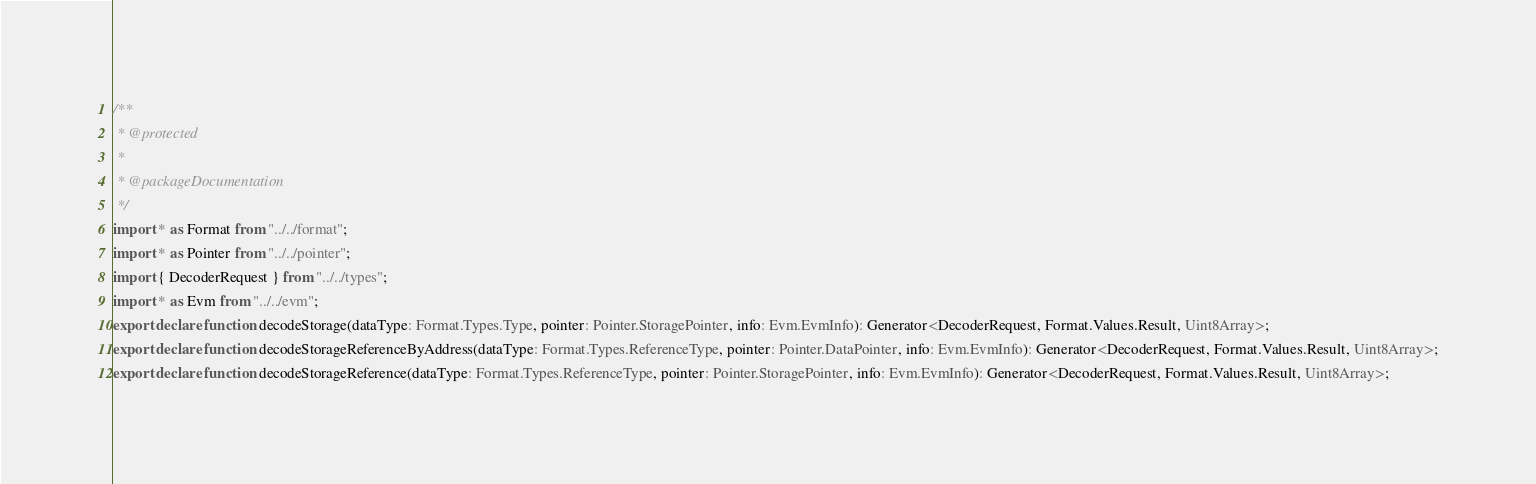Convert code to text. <code><loc_0><loc_0><loc_500><loc_500><_TypeScript_>/**
 * @protected
 *
 * @packageDocumentation
 */
import * as Format from "../../format";
import * as Pointer from "../../pointer";
import { DecoderRequest } from "../../types";
import * as Evm from "../../evm";
export declare function decodeStorage(dataType: Format.Types.Type, pointer: Pointer.StoragePointer, info: Evm.EvmInfo): Generator<DecoderRequest, Format.Values.Result, Uint8Array>;
export declare function decodeStorageReferenceByAddress(dataType: Format.Types.ReferenceType, pointer: Pointer.DataPointer, info: Evm.EvmInfo): Generator<DecoderRequest, Format.Values.Result, Uint8Array>;
export declare function decodeStorageReference(dataType: Format.Types.ReferenceType, pointer: Pointer.StoragePointer, info: Evm.EvmInfo): Generator<DecoderRequest, Format.Values.Result, Uint8Array>;
</code> 